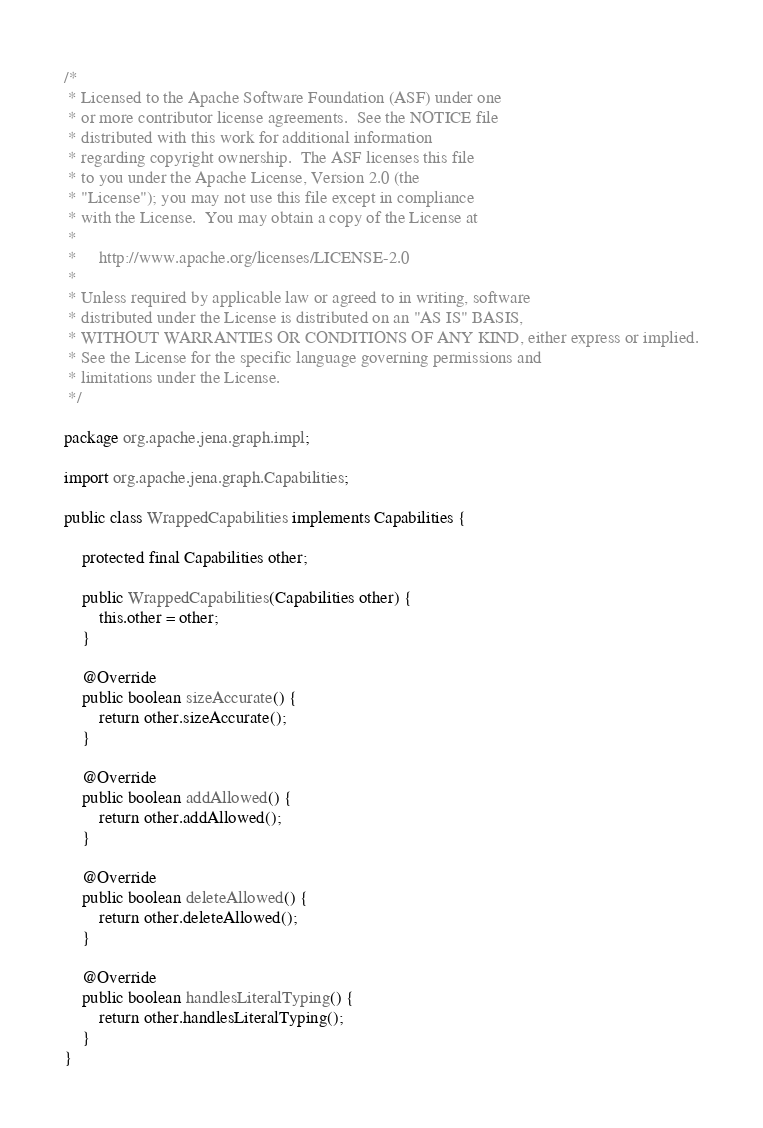Convert code to text. <code><loc_0><loc_0><loc_500><loc_500><_Java_>/*
 * Licensed to the Apache Software Foundation (ASF) under one
 * or more contributor license agreements.  See the NOTICE file
 * distributed with this work for additional information
 * regarding copyright ownership.  The ASF licenses this file
 * to you under the Apache License, Version 2.0 (the
 * "License"); you may not use this file except in compliance
 * with the License.  You may obtain a copy of the License at
 *
 *     http://www.apache.org/licenses/LICENSE-2.0
 *
 * Unless required by applicable law or agreed to in writing, software
 * distributed under the License is distributed on an "AS IS" BASIS,
 * WITHOUT WARRANTIES OR CONDITIONS OF ANY KIND, either express or implied.
 * See the License for the specific language governing permissions and
 * limitations under the License.
 */

package org.apache.jena.graph.impl;

import org.apache.jena.graph.Capabilities;

public class WrappedCapabilities implements Capabilities {

    protected final Capabilities other;

    public WrappedCapabilities(Capabilities other) {
        this.other = other;
    }

    @Override
    public boolean sizeAccurate() {
        return other.sizeAccurate();
    }

    @Override
    public boolean addAllowed() {
        return other.addAllowed();
    }

    @Override
    public boolean deleteAllowed() {
        return other.deleteAllowed();
    }

    @Override
    public boolean handlesLiteralTyping() {
        return other.handlesLiteralTyping();
    }
}
</code> 